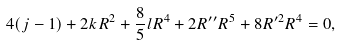<formula> <loc_0><loc_0><loc_500><loc_500>4 ( j - 1 ) + 2 k R ^ { 2 } + \frac { 8 } { 5 } l R ^ { 4 } + 2 R ^ { \prime \prime } R ^ { 5 } + 8 R ^ { \prime 2 } R ^ { 4 } = 0 ,</formula> 